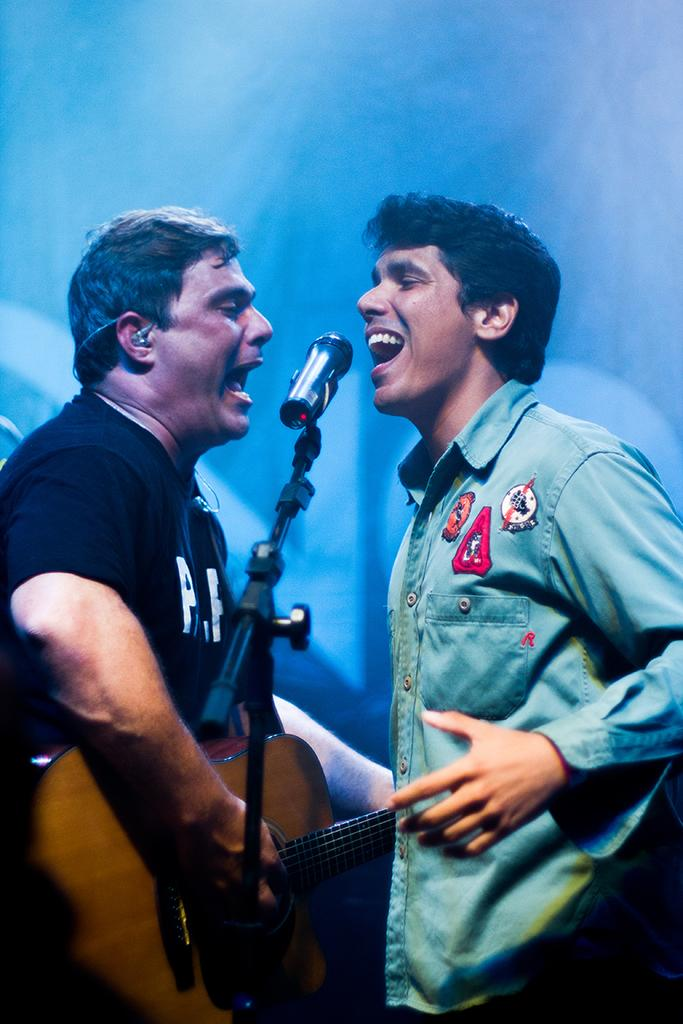How many people are in the image? There are two men in the image. What are the men doing in the image? The men are standing in front of a mic. What instrument is one of the men holding? One man is holding a guitar. What type of clover can be seen growing near the men in the image? There is no clover present in the image; it features two men standing in front of a mic, with one holding a guitar. 